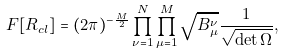Convert formula to latex. <formula><loc_0><loc_0><loc_500><loc_500>F [ { R } _ { c l } ] = ( 2 \pi ) ^ { - \frac { M } { 2 } } \prod _ { \nu = 1 } ^ { N } \prod _ { \mu = 1 } ^ { M } \sqrt { B _ { \mu } ^ { \nu } } \frac { 1 } { \sqrt { \det \Omega } } ,</formula> 